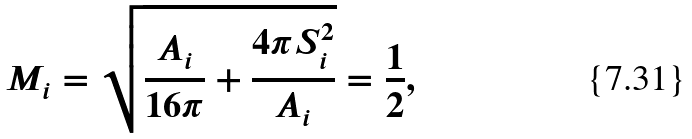<formula> <loc_0><loc_0><loc_500><loc_500>M _ { i } = \sqrt { \frac { A _ { i } } { 1 6 \pi } + \frac { 4 \pi S _ { i } ^ { 2 } } { A _ { i } } } = \frac { 1 } { 2 } ,</formula> 